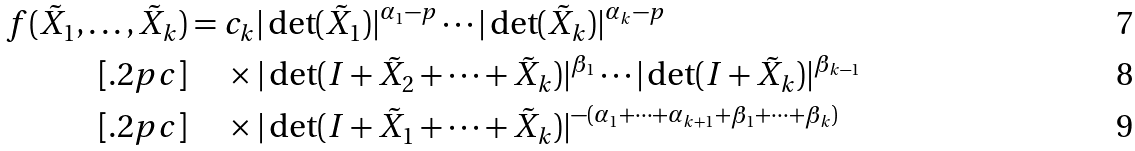Convert formula to latex. <formula><loc_0><loc_0><loc_500><loc_500>f ( \tilde { X } _ { 1 } , \dots , \tilde { X } _ { k } ) & = c _ { k } | \det ( \tilde { X } _ { 1 } ) | ^ { \alpha _ { 1 } - p } \cdots | \det ( \tilde { X } _ { k } ) | ^ { \alpha _ { k } - p } \\ [ . 2 p c ] & \quad \, \times | \det ( I + \tilde { X } _ { 2 } + \cdots + \tilde { X } _ { k } ) | ^ { \beta _ { 1 } } \cdots | \det ( I + \tilde { X } _ { k } ) | ^ { \beta _ { k - 1 } } \\ [ . 2 p c ] & \quad \, \times | \det ( I + \tilde { X } _ { 1 } + \cdots + \tilde { X } _ { k } ) | ^ { - ( \alpha _ { 1 } + \cdots + \alpha _ { k + 1 } + \beta _ { 1 } + \cdots + \beta _ { k } ) }</formula> 